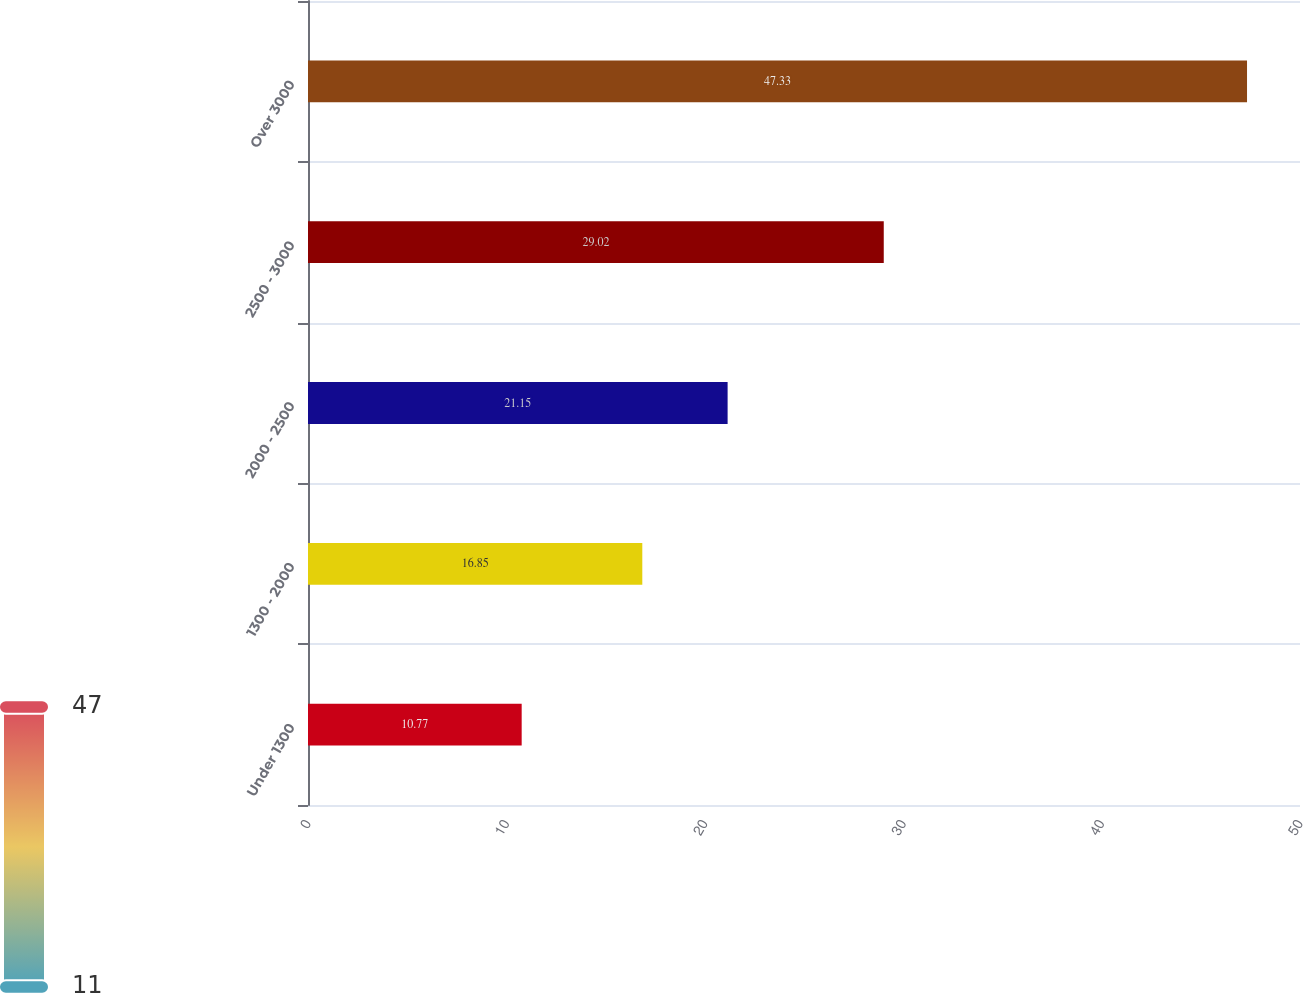<chart> <loc_0><loc_0><loc_500><loc_500><bar_chart><fcel>Under 1300<fcel>1300 - 2000<fcel>2000 - 2500<fcel>2500 - 3000<fcel>Over 3000<nl><fcel>10.77<fcel>16.85<fcel>21.15<fcel>29.02<fcel>47.33<nl></chart> 